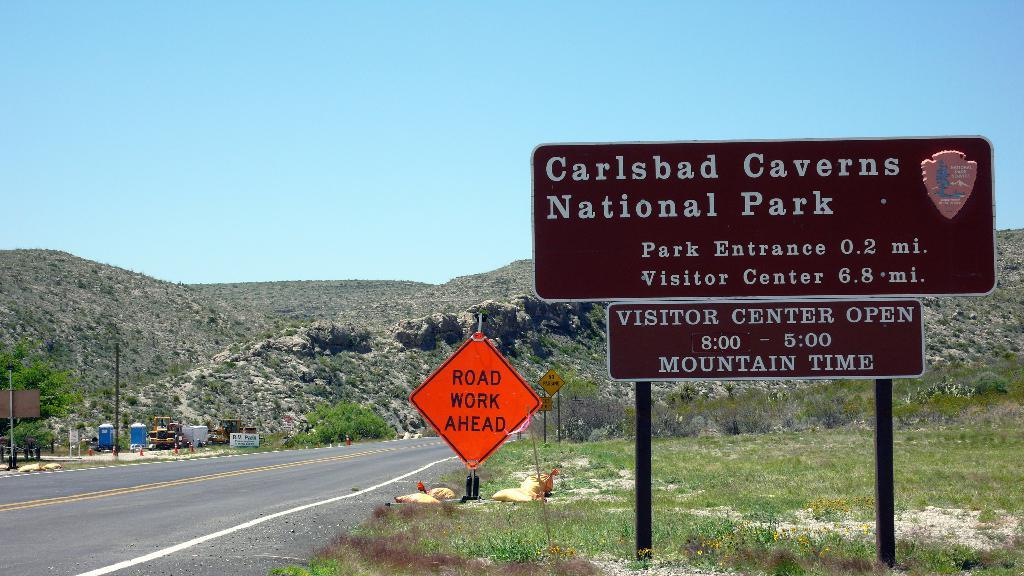<image>
Relay a brief, clear account of the picture shown. a carlsbad caverns national park sign that is outside 